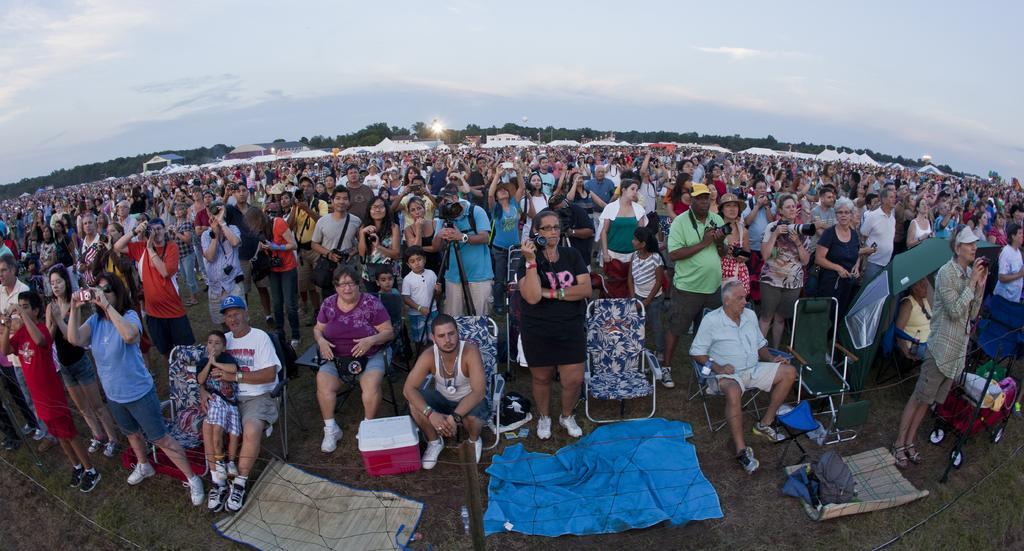How would you summarize this image in a sentence or two? This picture shows few people are standing and they are holding cameras in their hands and few people seated on the chairs and we see trees and a cloudy sky. 